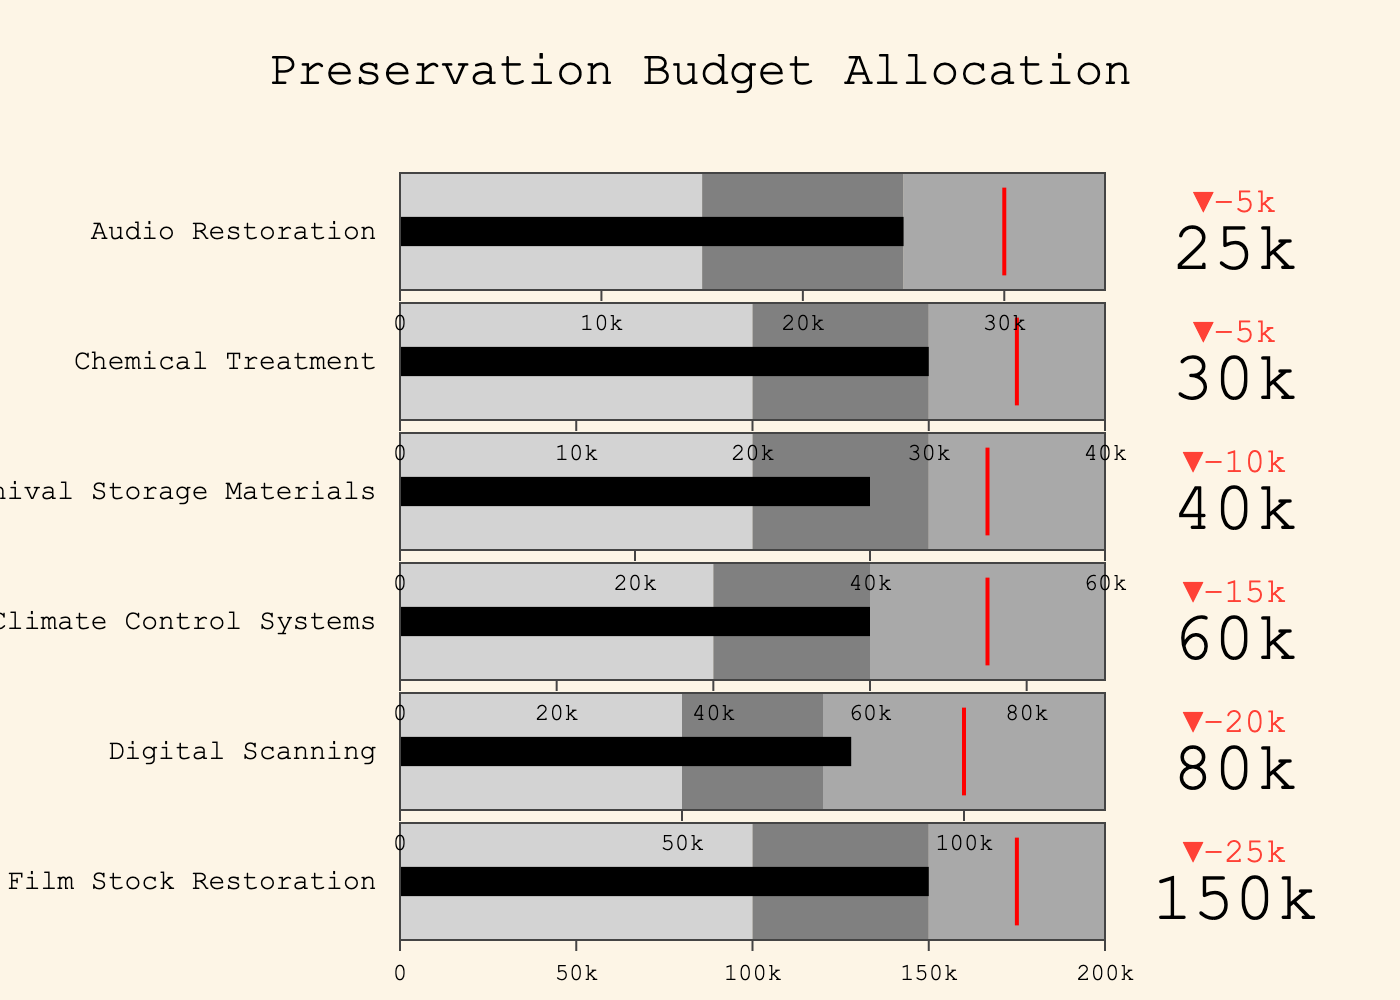What is the title of the figure? The title is located at the top of the figure and reads "Preservation Budget Allocation".
Answer: Preservation Budget Allocation Which preservation technique has the highest actual budget allocation? By observing the length of the black bars representing the actual budget, the longest bar belongs to "Film Stock Restoration".
Answer: Film Stock Restoration What is the target budget for Digital Scanning? The target budget for each category is marked by a red line inside the bullet chart. For Digital Scanning, the red line is at 100,000.
Answer: 100,000 How far is the actual budget from the target for Climate Control Systems? The actual budget for Climate Control Systems is 60,000, while the target is 75,000. The difference is 75,000 - 60,000 = 15,000.
Answer: 15,000 Which category is closest to reaching its target budget? The closest category is one where the black bar (actual budget) is nearest to the red line (target budget). "Film Stock Restoration" with 150,000 against a target of 175,000 is closest, being 25,000 away.
Answer: Film Stock Restoration How many categories are there in total? The figure has multiple bullet charts, each representing a different category. Counting them, we get a total of six categories.
Answer: Six What is the range covered by the darkest gray color in Audio Restoration? For Audio Restoration, the darkest gray area ranges from 25,000 to 35,000 as shown in the bullet chart.
Answer: 25,000 to 35,000 Which categories exceeded their Range1 but did not meet their Range2? To determine this, look for black bars surpassing Range1 but not reaching Range2. "Digital Scanning" (80,000 > 50,000 and < 75,000) and "Film Stock Restoration" (150,000 > 100,000 and <150,000) fall into this category.
Answer: Digital Scanning, Film Stock Restoration Compare the actual budget allocation for Archival Storage Materials and Chemical Treatment. Which is greater and by how much? The actual allocation for Archival Storage Materials is 40,000, while for Chemical Treatment, it is 30,000. The difference is 40,000 - 30,000 = 10,000.
Answer: Archival Storage Materials by 10,000 What is the average target budget across all categories? The target budgets are 175,000, 100,000, 75,000, 50,000, 35,000, and 30,000. Summing them gives 465,000. Dividing by the number of categories, the average is 465,000 / 6 = 77,500.
Answer: 77,500 